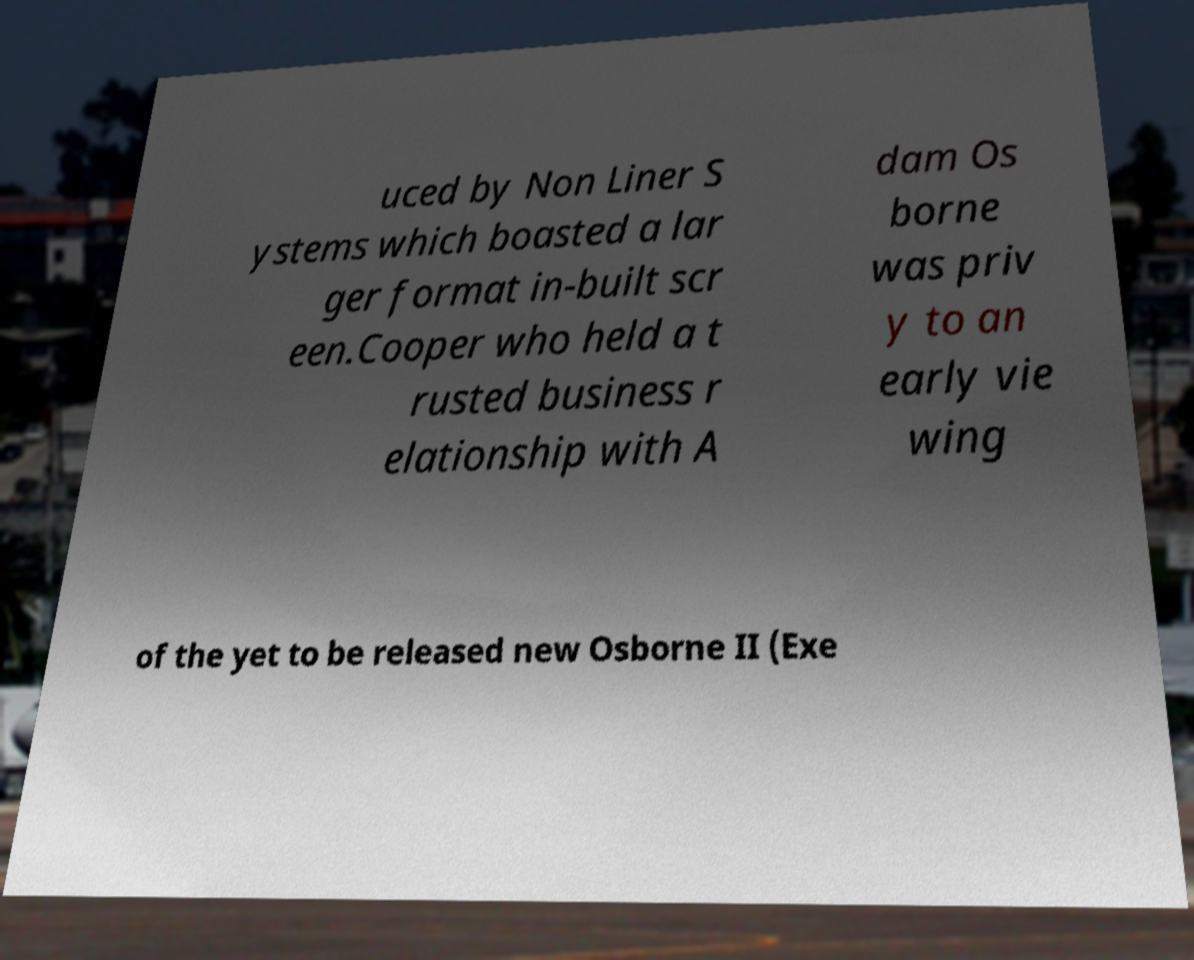Can you accurately transcribe the text from the provided image for me? uced by Non Liner S ystems which boasted a lar ger format in-built scr een.Cooper who held a t rusted business r elationship with A dam Os borne was priv y to an early vie wing of the yet to be released new Osborne II (Exe 